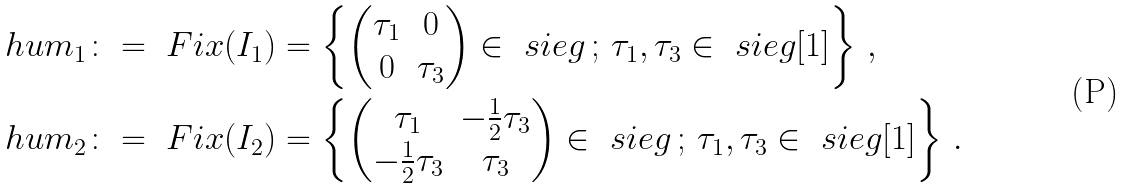<formula> <loc_0><loc_0><loc_500><loc_500>& \ h u m _ { 1 } \colon = \ F i x ( I _ { 1 } ) = \left \{ \begin{pmatrix} \tau _ { 1 } & 0 \\ 0 & \tau _ { 3 } \end{pmatrix} \in \ s i e g \, ; \, \tau _ { 1 } , \tau _ { 3 } \in \ s i e g [ 1 ] \right \} \, , \\ & \ h u m _ { 2 } \colon = \ F i x ( I _ { 2 } ) = \left \{ \begin{pmatrix} \tau _ { 1 } & - \frac { 1 } { 2 } \tau _ { 3 } \\ - \frac { 1 } { 2 } \tau _ { 3 } & \tau _ { 3 } \end{pmatrix} \in \ s i e g \, ; \, \tau _ { 1 } , \tau _ { 3 } \in \ s i e g [ 1 ] \right \} \, .</formula> 